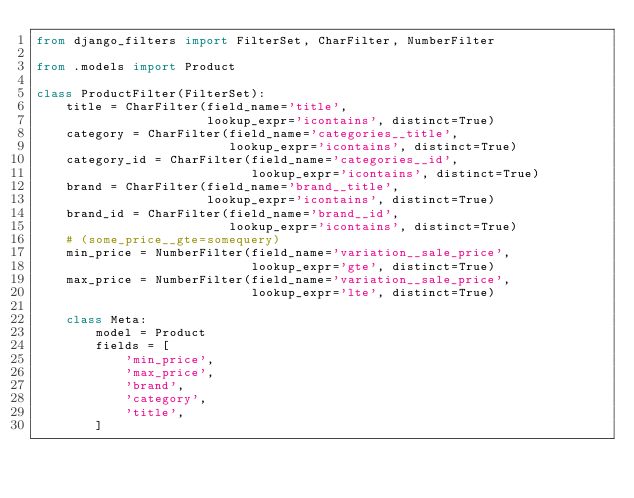Convert code to text. <code><loc_0><loc_0><loc_500><loc_500><_Python_>from django_filters import FilterSet, CharFilter, NumberFilter

from .models import Product

class ProductFilter(FilterSet):
    title = CharFilter(field_name='title',
                       lookup_expr='icontains', distinct=True)
    category = CharFilter(field_name='categories__title',
                          lookup_expr='icontains', distinct=True)
    category_id = CharFilter(field_name='categories__id',
                             lookup_expr='icontains', distinct=True)
    brand = CharFilter(field_name='brand__title',
                       lookup_expr='icontains', distinct=True)
    brand_id = CharFilter(field_name='brand__id',
                          lookup_expr='icontains', distinct=True)
    # (some_price__gte=somequery)
    min_price = NumberFilter(field_name='variation__sale_price',
                             lookup_expr='gte', distinct=True)
    max_price = NumberFilter(field_name='variation__sale_price',
                             lookup_expr='lte', distinct=True)

    class Meta:
        model = Product
        fields = [
            'min_price',
            'max_price',
            'brand',
            'category',
            'title',
        ]</code> 